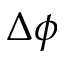<formula> <loc_0><loc_0><loc_500><loc_500>\Delta \phi</formula> 